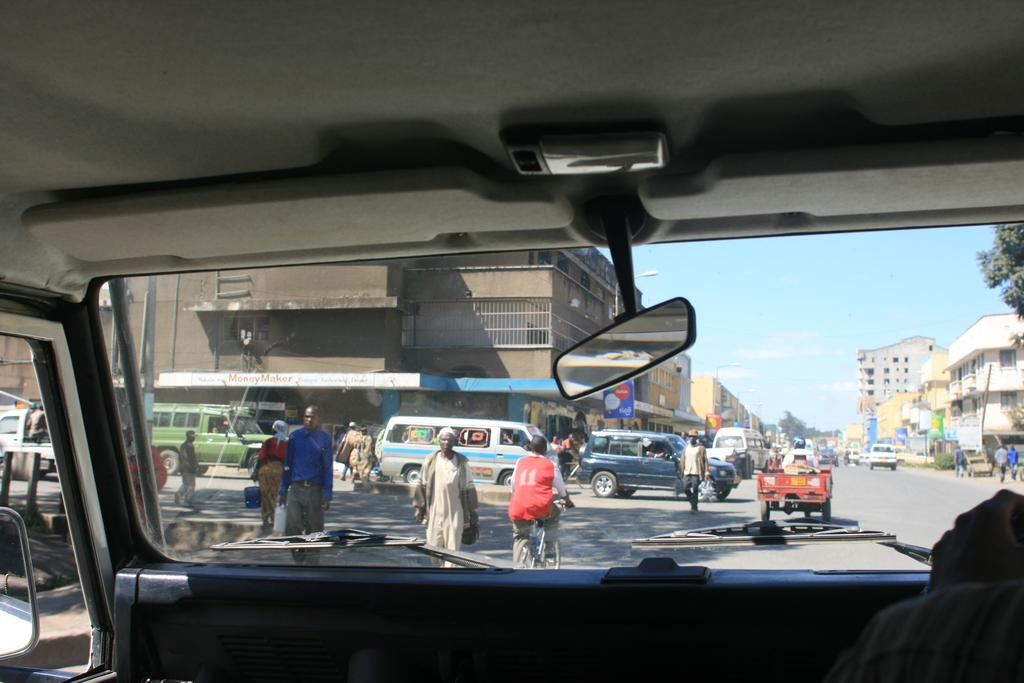Where was the image taken from? The image was taken from inside a car. What can be seen on the road in front of the car? There are many vehicles on the road in front of the car. Are there any people visible in the image? Yes, there are people on the road. What is visible on either side of the road? There are buildings on either side of the road. What is visible above the buildings? The sky is visible above the buildings. Can you describe the sky in the image? Clouds are present in the sky. What type of industry can be seen in the image? There is no specific industry visible in the image; it shows a road with vehicles, people, and buildings. Is there any indication of an attack happening in the image? No, there is no indication of an attack in the image. 